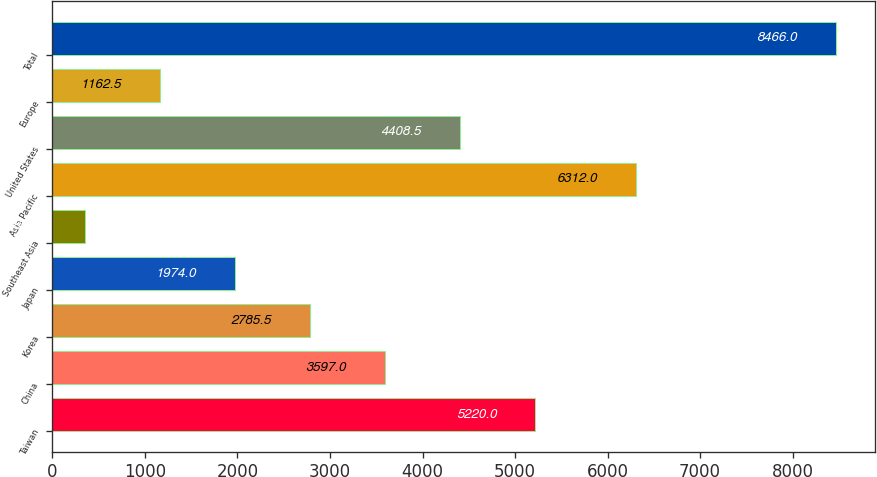<chart> <loc_0><loc_0><loc_500><loc_500><bar_chart><fcel>Taiwan<fcel>China<fcel>Korea<fcel>Japan<fcel>Southeast Asia<fcel>Asia Pacific<fcel>United States<fcel>Europe<fcel>Total<nl><fcel>5220<fcel>3597<fcel>2785.5<fcel>1974<fcel>351<fcel>6312<fcel>4408.5<fcel>1162.5<fcel>8466<nl></chart> 